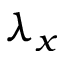<formula> <loc_0><loc_0><loc_500><loc_500>\lambda _ { x }</formula> 